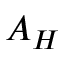<formula> <loc_0><loc_0><loc_500><loc_500>A _ { H }</formula> 